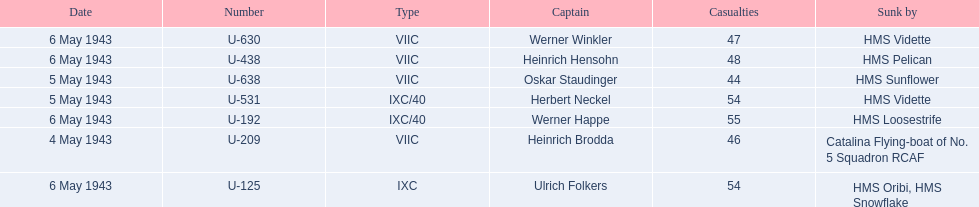Who are the captains of the u boats? Heinrich Brodda, Oskar Staudinger, Herbert Neckel, Werner Happe, Ulrich Folkers, Werner Winkler, Heinrich Hensohn. What are the dates the u boat captains were lost? 4 May 1943, 5 May 1943, 5 May 1943, 6 May 1943, 6 May 1943, 6 May 1943, 6 May 1943. Of these, which were lost on may 5? Oskar Staudinger, Herbert Neckel. Other than oskar staudinger, who else was lost on this day? Herbert Neckel. 